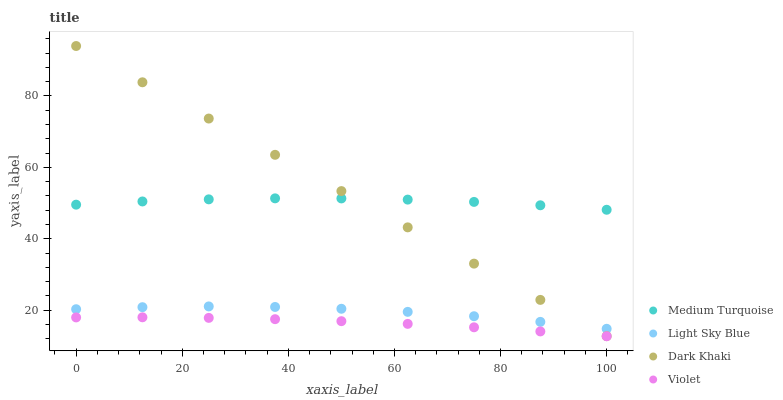Does Violet have the minimum area under the curve?
Answer yes or no. Yes. Does Dark Khaki have the maximum area under the curve?
Answer yes or no. Yes. Does Light Sky Blue have the minimum area under the curve?
Answer yes or no. No. Does Light Sky Blue have the maximum area under the curve?
Answer yes or no. No. Is Dark Khaki the smoothest?
Answer yes or no. Yes. Is Light Sky Blue the roughest?
Answer yes or no. Yes. Is Medium Turquoise the smoothest?
Answer yes or no. No. Is Medium Turquoise the roughest?
Answer yes or no. No. Does Violet have the lowest value?
Answer yes or no. Yes. Does Light Sky Blue have the lowest value?
Answer yes or no. No. Does Dark Khaki have the highest value?
Answer yes or no. Yes. Does Light Sky Blue have the highest value?
Answer yes or no. No. Is Violet less than Medium Turquoise?
Answer yes or no. Yes. Is Dark Khaki greater than Violet?
Answer yes or no. Yes. Does Light Sky Blue intersect Dark Khaki?
Answer yes or no. Yes. Is Light Sky Blue less than Dark Khaki?
Answer yes or no. No. Is Light Sky Blue greater than Dark Khaki?
Answer yes or no. No. Does Violet intersect Medium Turquoise?
Answer yes or no. No. 